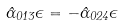<formula> <loc_0><loc_0><loc_500><loc_500>\hat { \Gamma } _ { 0 1 3 } \epsilon = - \hat { \Gamma } _ { 0 2 4 } \epsilon</formula> 